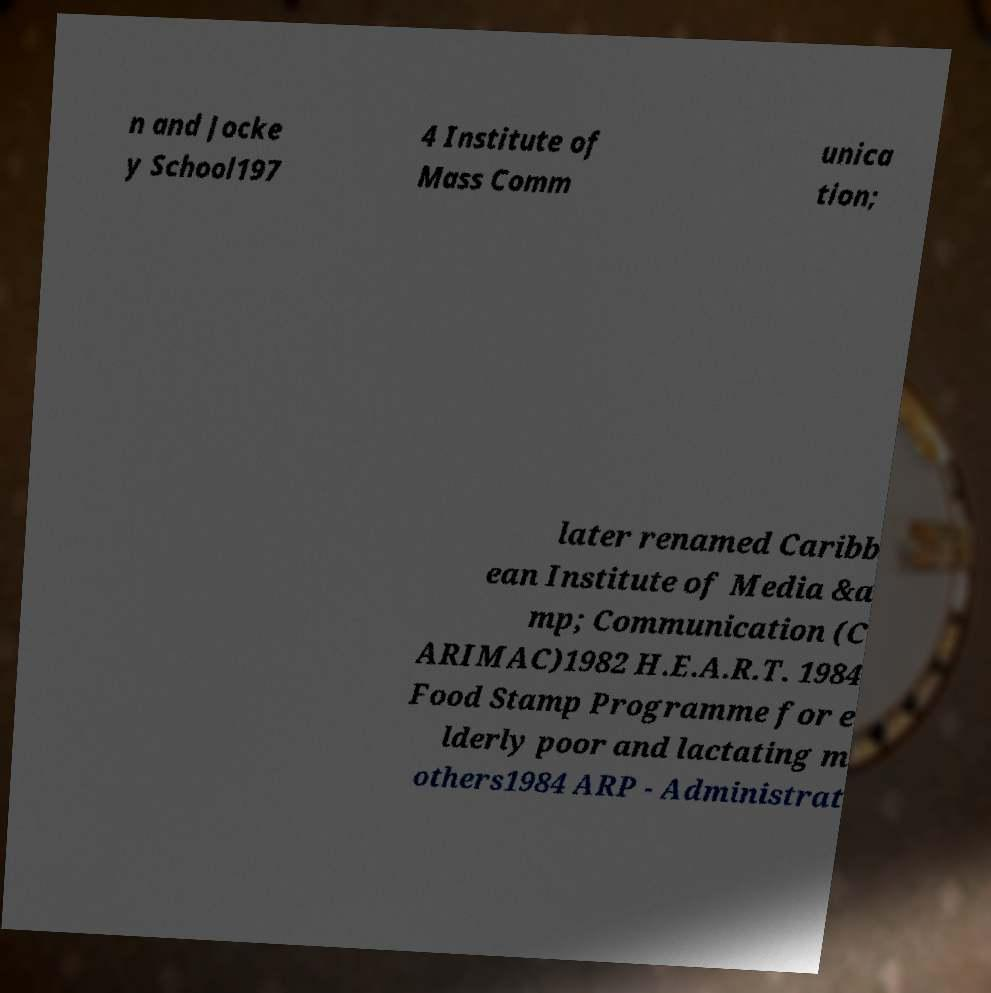Could you assist in decoding the text presented in this image and type it out clearly? n and Jocke y School197 4 Institute of Mass Comm unica tion; later renamed Caribb ean Institute of Media &a mp; Communication (C ARIMAC)1982 H.E.A.R.T. 1984 Food Stamp Programme for e lderly poor and lactating m others1984 ARP - Administrat 